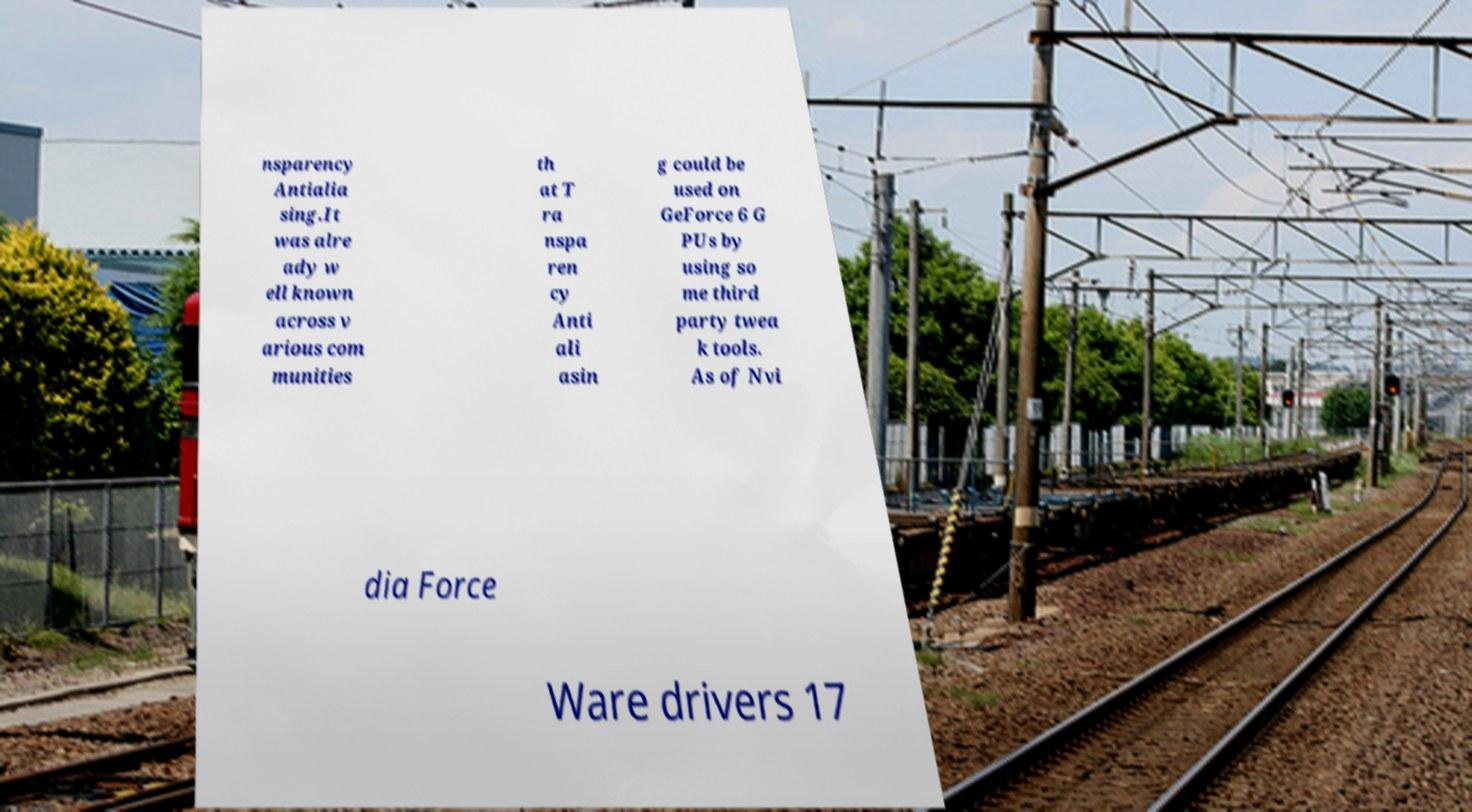Could you assist in decoding the text presented in this image and type it out clearly? nsparency Antialia sing.It was alre ady w ell known across v arious com munities th at T ra nspa ren cy Anti ali asin g could be used on GeForce 6 G PUs by using so me third party twea k tools. As of Nvi dia Force Ware drivers 17 